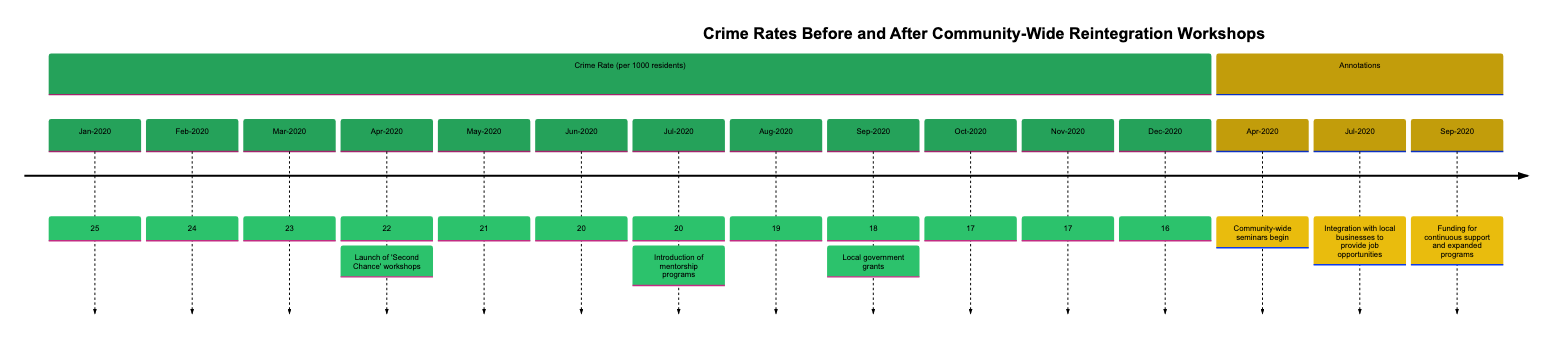What was the crime rate in January 2020? The diagram shows that the crime rate in January 2020 is indicated by a value at that specific point on the line chart, which is 25.
Answer: 25 What significant event occurred in April 2020? The graph has an annotation indicating that the 'Second Chance' workshops were launched in April 2020, marking a key intervention for community reintegration.
Answer: Launch of 'Second Chance' workshops What is the lowest crime rate recorded in the diagram? By evaluating the values in the chart, the lowest crime rate appears to be 16, recorded in December 2020, which is the minimum value plotted on the line.
Answer: 16 How many interventions are annotated in the timeline? The diagram shows three notable interventions marked by annotations in the timeline. These interventions are the launch of workshops, integration with local businesses, and funding for continuous support.
Answer: 3 What was the crime rate change from March 2020 to October 2020? By comparing the values for these months, in March 2020 the crime rate was 23 and in October 2020 it was 17. The change is calculated as 23 minus 17, which equals 6.
Answer: 6 What is the crime rate after the introduction of mentorship programs? After the mentorship programs were introduced in July 2020, the recorded crime rate is 20, as seen on the chart at that node.
Answer: 20 What does the line graph indicate about crime rates from before to after September 2020? By analyzing the trend, the graph shows a consistent decline in the crime rate before but a notable decrease up to September 2020, illustrating the impact of community policies and workshops.
Answer: Declining trend What was the crime rate immediately prior to the local government grants in September 2020? The month immediately before September 2020 is August 2020, where the crime rate is indicated as 19, thus representing the value prior to the local government grants.
Answer: 19 What was the crime rate in December 2020? Directly looking at the last month represented in the diagram, December 2020 shows a crime rate of 16, which can be found at the corresponding position on the timeline.
Answer: 16 